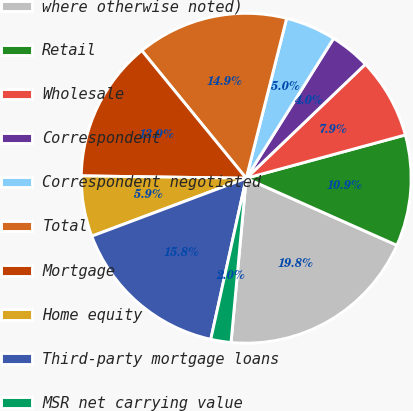Convert chart to OTSL. <chart><loc_0><loc_0><loc_500><loc_500><pie_chart><fcel>where otherwise noted)<fcel>Retail<fcel>Wholesale<fcel>Correspondent<fcel>Correspondent negotiated<fcel>Total<fcel>Mortgage<fcel>Home equity<fcel>Third-party mortgage loans<fcel>MSR net carrying value<nl><fcel>19.8%<fcel>10.89%<fcel>7.92%<fcel>3.96%<fcel>4.95%<fcel>14.85%<fcel>13.86%<fcel>5.94%<fcel>15.84%<fcel>1.98%<nl></chart> 